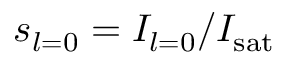Convert formula to latex. <formula><loc_0><loc_0><loc_500><loc_500>s _ { l = 0 } = I _ { l = 0 } / I _ { s a t }</formula> 